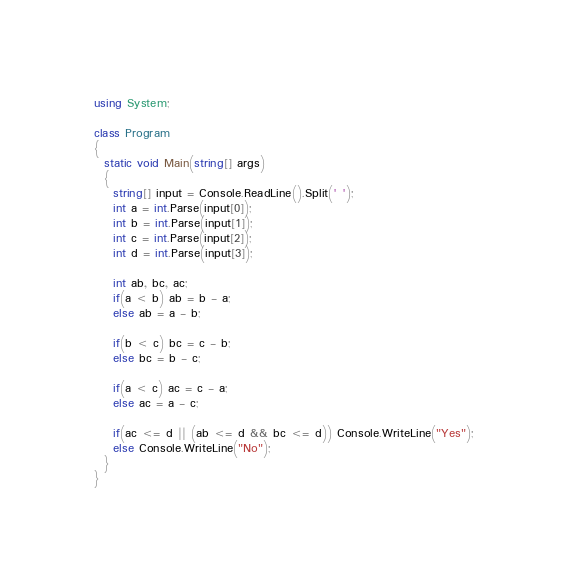<code> <loc_0><loc_0><loc_500><loc_500><_C#_>using System;

class Program
{
  static void Main(string[] args)
  {
    string[] input = Console.ReadLine().Split(' ');
    int a = int.Parse(input[0]);
    int b = int.Parse(input[1]);
    int c = int.Parse(input[2]);
    int d = int.Parse(input[3]);
    
    int ab, bc, ac;
    if(a < b) ab = b - a;
    else ab = a - b;
  
    if(b < c) bc = c - b;
    else bc = b - c;
  
    if(a < c) ac = c - a;
    else ac = a - c;
  
    if(ac <= d || (ab <= d && bc <= d)) Console.WriteLine("Yes");
    else Console.WriteLine("No");
  }
}</code> 